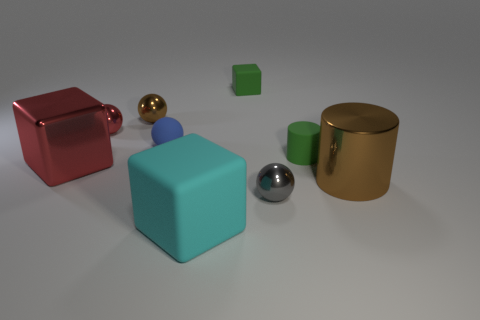Can you tell me the purpose of this arrangement of objects? This arrangement of objects appears to be a synthetic composition, possibly designed for visual or artistic purposes. Each object's distinct shape, color, and material offers a study in contrast and comparison. Such a setup is often used in 3D modeling and rendering to test the effects of lighting and shadows, as well as material properties like reflection and texture. 